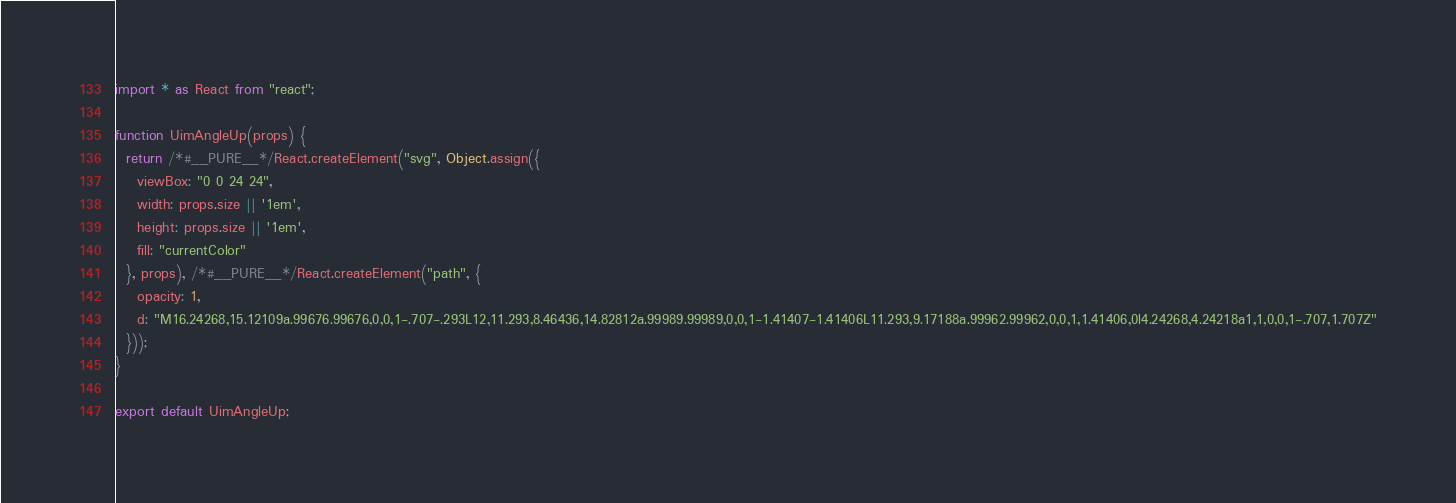Convert code to text. <code><loc_0><loc_0><loc_500><loc_500><_JavaScript_>import * as React from "react";

function UimAngleUp(props) {
  return /*#__PURE__*/React.createElement("svg", Object.assign({
    viewBox: "0 0 24 24",
    width: props.size || '1em',
    height: props.size || '1em',
    fill: "currentColor"
  }, props), /*#__PURE__*/React.createElement("path", {
    opacity: 1,
    d: "M16.24268,15.12109a.99676.99676,0,0,1-.707-.293L12,11.293,8.46436,14.82812a.99989.99989,0,0,1-1.41407-1.41406L11.293,9.17188a.99962.99962,0,0,1,1.41406,0l4.24268,4.24218a1,1,0,0,1-.707,1.707Z"
  }));
}

export default UimAngleUp;</code> 